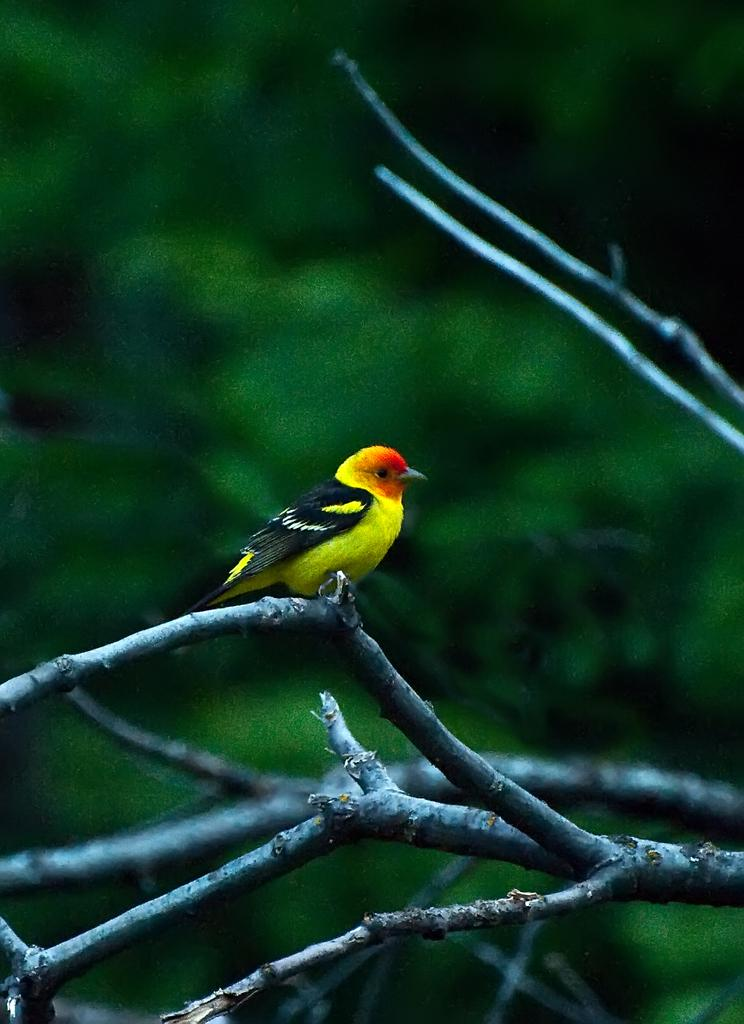What type of animal can be seen in the image? There is a bird in the image. Where is the bird located in the image? The bird is in the center of the image. What is the bird standing on? The bird is on a branch. What month is it in the image? The month cannot be determined from the image, as it does not contain any information about the time of year. 